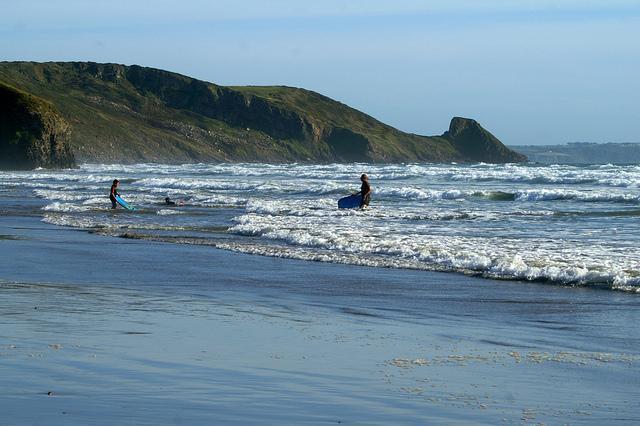How many surfers are in the water?
Give a very brief answer. 2. How many people are between the two orange buses in the image?
Give a very brief answer. 0. 